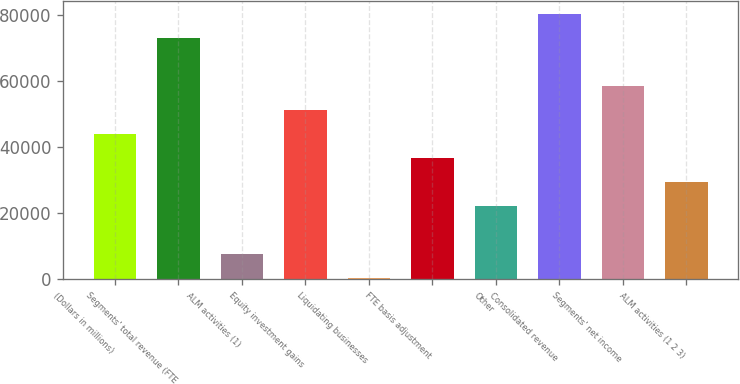Convert chart. <chart><loc_0><loc_0><loc_500><loc_500><bar_chart><fcel>(Dollars in millions)<fcel>Segments' total revenue (FTE<fcel>ALM activities (1)<fcel>Equity investment gains<fcel>Liquidating businesses<fcel>FTE basis adjustment<fcel>Other<fcel>Consolidated revenue<fcel>Segments' net income<fcel>ALM activities (1 2 3)<nl><fcel>43920.6<fcel>73023<fcel>7542.6<fcel>51196.2<fcel>267<fcel>36645<fcel>22093.8<fcel>80298.6<fcel>58471.8<fcel>29369.4<nl></chart> 